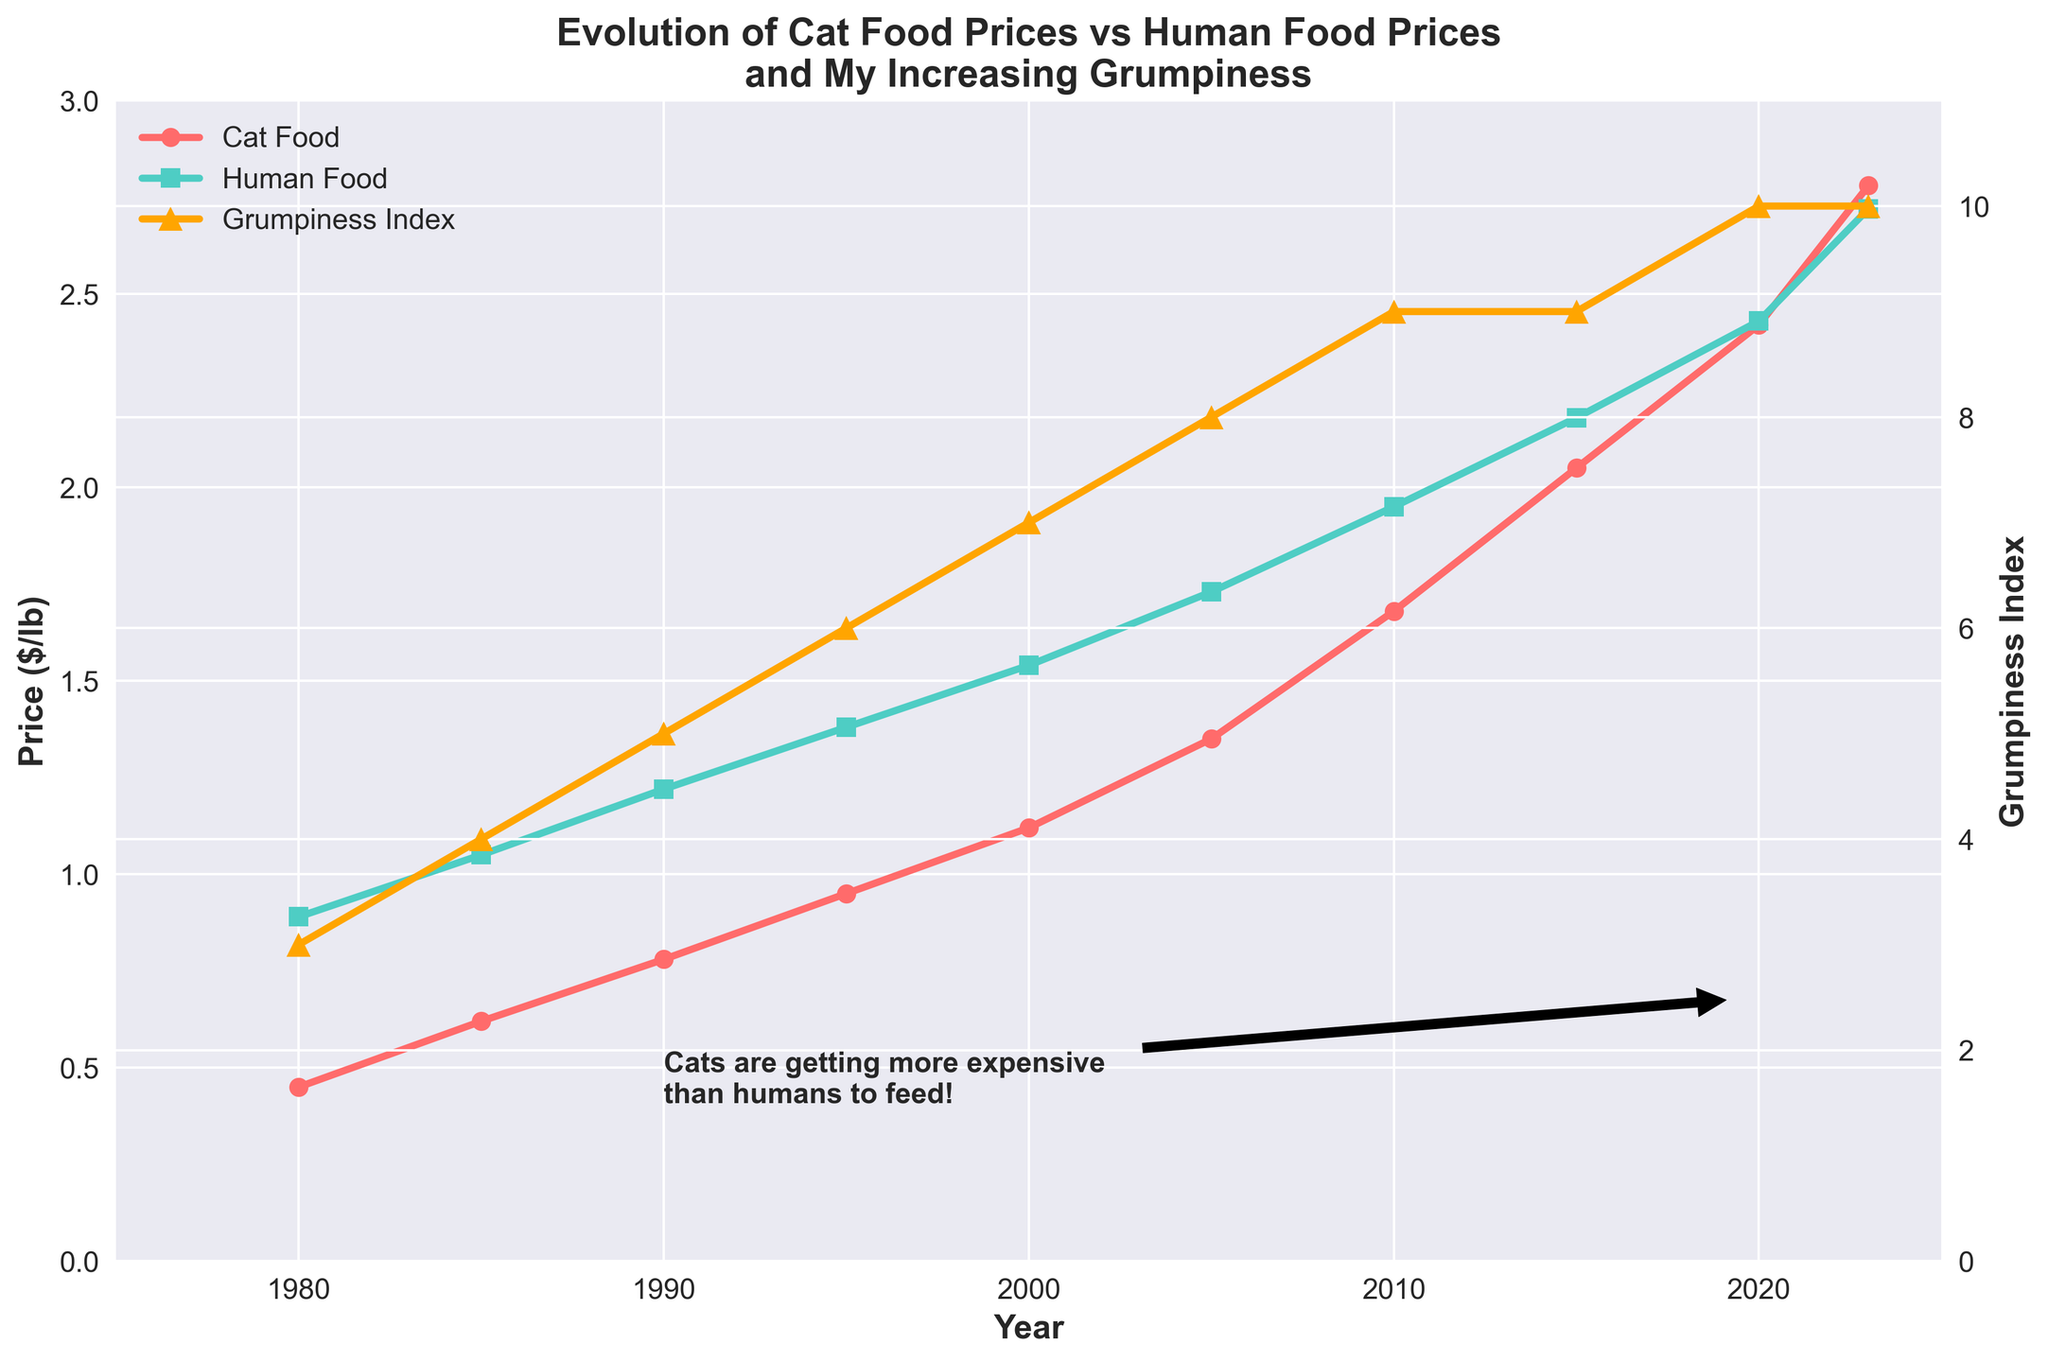What is the trend of cat food prices from 1980 to 2023? From the figure, cat food prices show a consistent upward trend from 1980 ($0.45) to 2023 ($2.78), indicating a steady increase over the years.
Answer: Upward trend In which year did the cat food price surpass human food price for the first time? By examining the two lines, cat food prices surpass human food prices around 2020, where the cat food price is at $2.42 and human food price is at $2.43.
Answer: 2020 Which type of food had a faster price increase rate from 1980 to 2023? Both lines show an increase in prices, but the cat food price line is steeper compared to human food price line, indicating a faster rate of increase for cat food.
Answer: Cat food By how much did the grumpiness index increase from 1980 to 2023? The grumpiness index in 1980 is 3 and in 2023 is 10. The increase is calculated as 10 - 3.
Answer: 7 In what year did the grumpiness index stabilize despite the rise in cat food prices? The grumpiness index hits its peak (10) in 2020 and remains stable at that level in 2023, even though cat food prices continued to rise.
Answer: 2020 Compare the prices of human food and cat food in 1995. Which one was higher and by how much? In 1995, the price of human food was $1.38 and the price of cat food was $0.95. The difference is calculated as $1.38 - $0.95.
Answer: Human food by $0.43 What is the grumpiness index value when cat food is priced at approximately $2.05? By checking the plot, when cat food price is around $2.05 (in 2015), the grumpiness index value is 9.
Answer: 9 What is the average price of cat food over the years recorded? To get the average, sum the cat food prices (0.45 + 0.62 + 0.78 + 0.95 + 1.12 + 1.35 + 1.68 + 2.05 + 2.42 + 2.78) and divide by number of data points (10). The sum is 14.2, so: 14.2 / 10 = 1.42.
Answer: $1.42 From the visual annotation, what significant observation is highlighted around 2020? The annotation around 2020 highlights that cat food has become more expensive than human food, emphasizing how expensive feeding cats has become.
Answer: Cats more expensive 